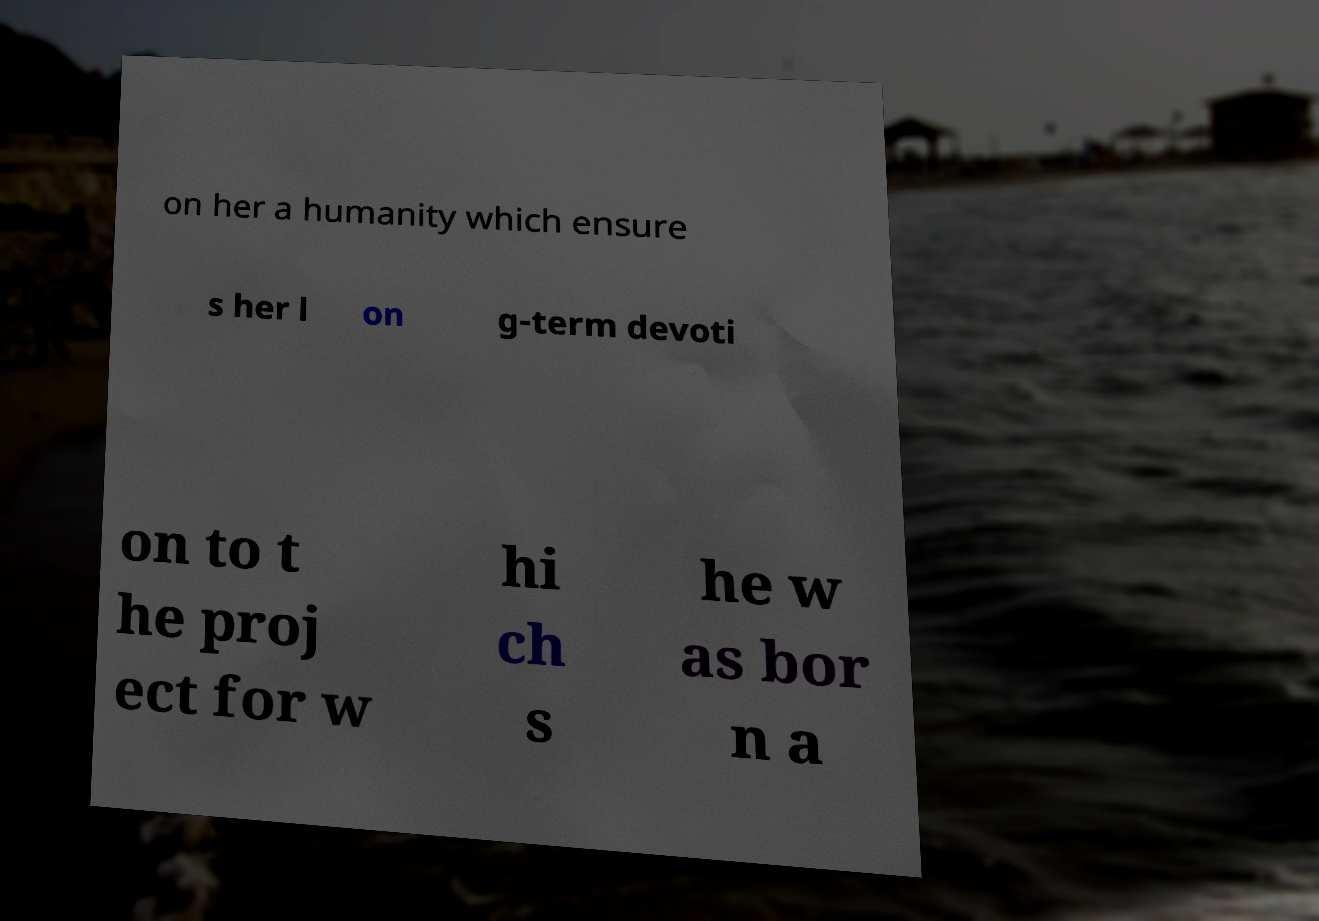Could you extract and type out the text from this image? on her a humanity which ensure s her l on g-term devoti on to t he proj ect for w hi ch s he w as bor n a 